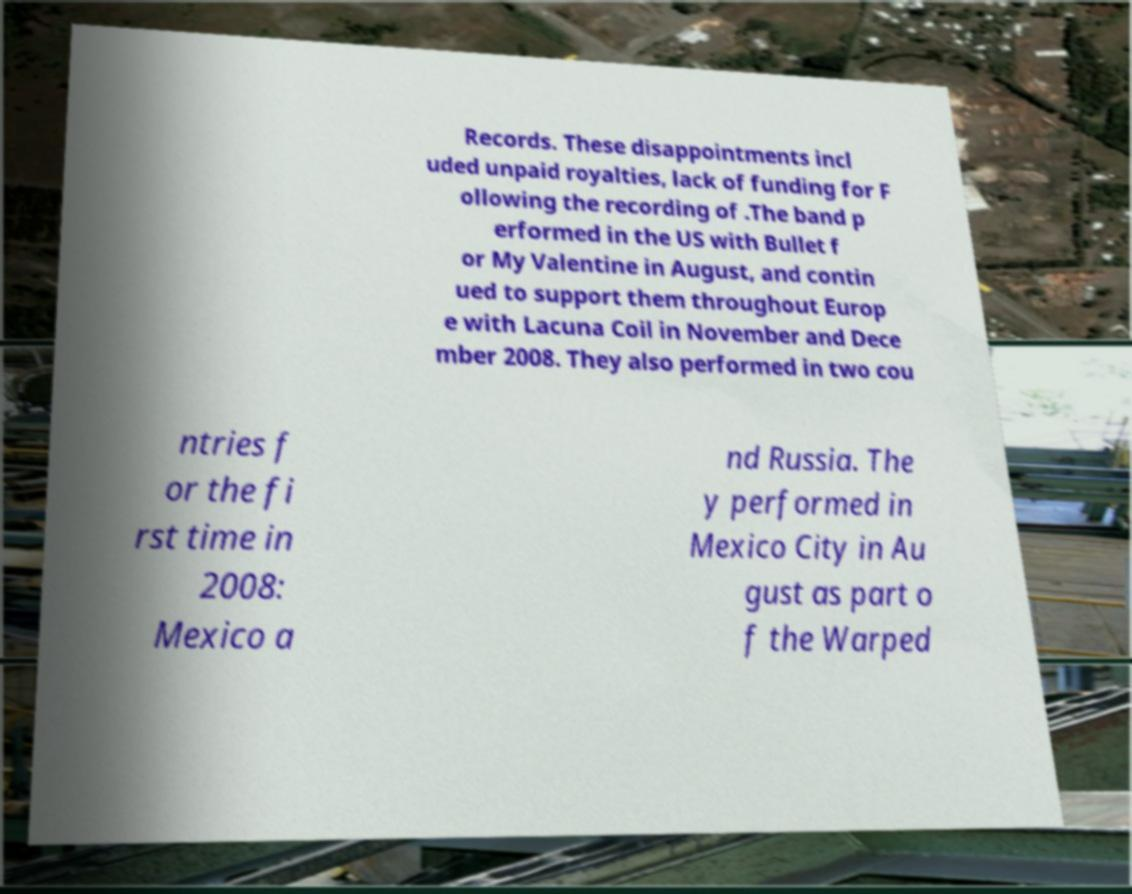Could you assist in decoding the text presented in this image and type it out clearly? Records. These disappointments incl uded unpaid royalties, lack of funding for F ollowing the recording of .The band p erformed in the US with Bullet f or My Valentine in August, and contin ued to support them throughout Europ e with Lacuna Coil in November and Dece mber 2008. They also performed in two cou ntries f or the fi rst time in 2008: Mexico a nd Russia. The y performed in Mexico City in Au gust as part o f the Warped 